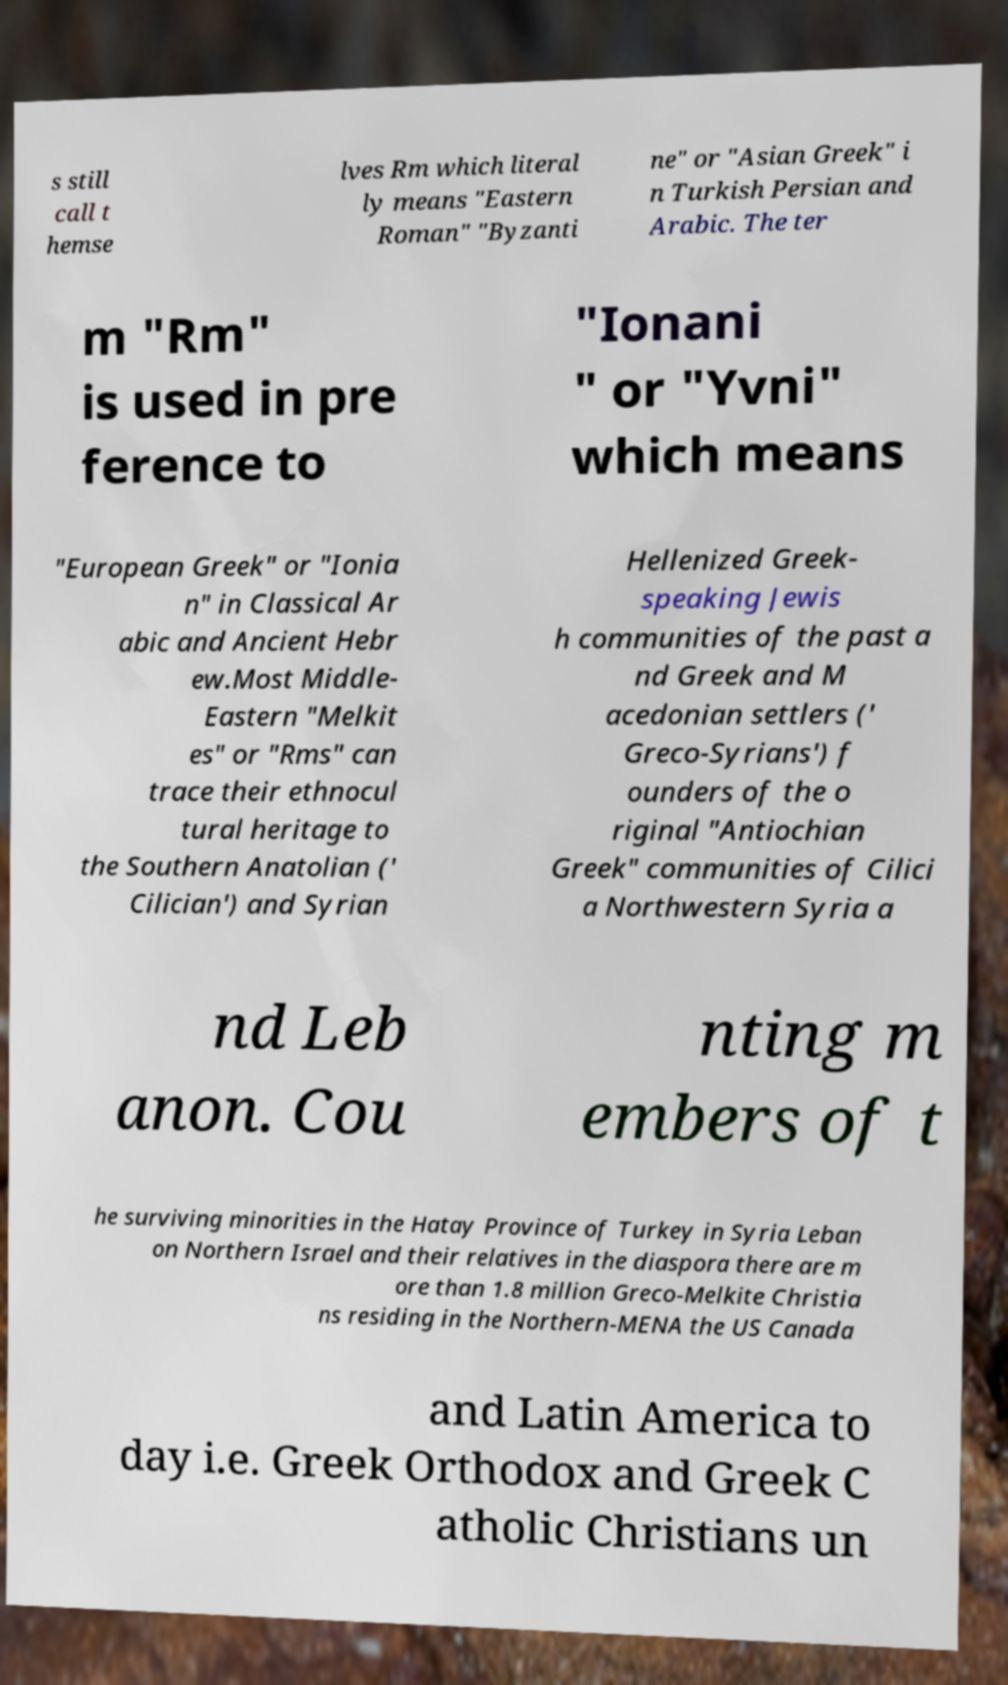Please read and relay the text visible in this image. What does it say? s still call t hemse lves Rm which literal ly means "Eastern Roman" "Byzanti ne" or "Asian Greek" i n Turkish Persian and Arabic. The ter m "Rm" is used in pre ference to "Ionani " or "Yvni" which means "European Greek" or "Ionia n" in Classical Ar abic and Ancient Hebr ew.Most Middle- Eastern "Melkit es" or "Rms" can trace their ethnocul tural heritage to the Southern Anatolian (' Cilician') and Syrian Hellenized Greek- speaking Jewis h communities of the past a nd Greek and M acedonian settlers (' Greco-Syrians') f ounders of the o riginal "Antiochian Greek" communities of Cilici a Northwestern Syria a nd Leb anon. Cou nting m embers of t he surviving minorities in the Hatay Province of Turkey in Syria Leban on Northern Israel and their relatives in the diaspora there are m ore than 1.8 million Greco-Melkite Christia ns residing in the Northern-MENA the US Canada and Latin America to day i.e. Greek Orthodox and Greek C atholic Christians un 